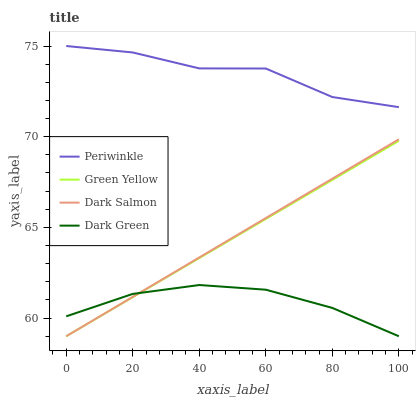Does Dark Green have the minimum area under the curve?
Answer yes or no. Yes. Does Periwinkle have the maximum area under the curve?
Answer yes or no. Yes. Does Dark Salmon have the minimum area under the curve?
Answer yes or no. No. Does Dark Salmon have the maximum area under the curve?
Answer yes or no. No. Is Green Yellow the smoothest?
Answer yes or no. Yes. Is Periwinkle the roughest?
Answer yes or no. Yes. Is Dark Salmon the smoothest?
Answer yes or no. No. Is Dark Salmon the roughest?
Answer yes or no. No. Does Green Yellow have the lowest value?
Answer yes or no. Yes. Does Periwinkle have the lowest value?
Answer yes or no. No. Does Periwinkle have the highest value?
Answer yes or no. Yes. Does Dark Salmon have the highest value?
Answer yes or no. No. Is Green Yellow less than Periwinkle?
Answer yes or no. Yes. Is Periwinkle greater than Green Yellow?
Answer yes or no. Yes. Does Green Yellow intersect Dark Green?
Answer yes or no. Yes. Is Green Yellow less than Dark Green?
Answer yes or no. No. Is Green Yellow greater than Dark Green?
Answer yes or no. No. Does Green Yellow intersect Periwinkle?
Answer yes or no. No. 